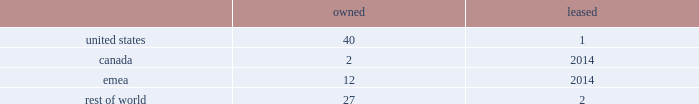Volatility of capital markets or macroeconomic factors could adversely affect our business .
Changes in financial and capital markets , including market disruptions , limited liquidity , uncertainty regarding brexit , and interest rate volatility , including as a result of the use or discontinued use of certain benchmark rates such as libor , may increase the cost of financing as well as the risks of refinancing maturing debt .
In addition , our borrowing costs can be affected by short and long-term ratings assigned by rating organizations .
A decrease in these ratings could limit our access to capital markets and increase our borrowing costs , which could materially and adversely affect our financial condition and operating results .
Some of our customers and counterparties are highly leveraged .
Consolidations in some of the industries in which our customers operate have created larger customers , some of which are highly leveraged and facing increased competition and continued credit market volatility .
These factors have caused some customers to be less profitable , increasing our exposure to credit risk .
A significant adverse change in the financial and/or credit position of a customer or counterparty could require us to assume greater credit risk relating to that customer or counterparty and could limit our ability to collect receivables .
This could have an adverse impact on our financial condition and liquidity .
Item 1b .
Unresolved staff comments .
Item 2 .
Properties .
Our corporate co-headquarters are located in pittsburgh , pennsylvania and chicago , illinois .
Our co-headquarters are leased and house certain executive offices , our u.s .
Business units , and our administrative , finance , legal , and human resource functions .
We maintain additional owned and leased offices throughout the regions in which we operate .
We manufacture our products in our network of manufacturing and processing facilities located throughout the world .
As of december 29 , 2018 , we operated 84 manufacturing and processing facilities .
We own 81 and lease three of these facilities .
Our manufacturing and processing facilities count by segment as of december 29 , 2018 was: .
We maintain all of our manufacturing and processing facilities in good condition and believe they are suitable and are adequate for our present needs .
We also enter into co-manufacturing arrangements with third parties if we determine it is advantageous to outsource the production of any of our products .
In the fourth quarter of 2018 , we announced our plans to divest certain assets and operations , predominantly in canada and india , including one owned manufacturing facility in canada and one owned and one leased facility in india .
See note 5 , acquisitions and divestitures , in item 8 , financial statements and supplementary data , for additional information on these transactions .
Item 3 .
Legal proceedings .
See note 18 , commitments and contingencies , in item 8 , financial statements and supplementary data .
Item 4 .
Mine safety disclosures .
Not applicable .
Part ii item 5 .
Market for registrant's common equity , related stockholder matters and issuer purchases of equity securities .
Our common stock is listed on nasdaq under the ticker symbol 201ckhc 201d .
At june 5 , 2019 , there were approximately 49000 holders of record of our common stock .
See equity and dividends in item 7 , management 2019s discussion and analysis of financial condition and results of operations , for a discussion of cash dividends declared on our common stock. .
What is the portion of total number of facilities located in the rest of the world? 
Computations: ((27 + 2) / 84)
Answer: 0.34524. 